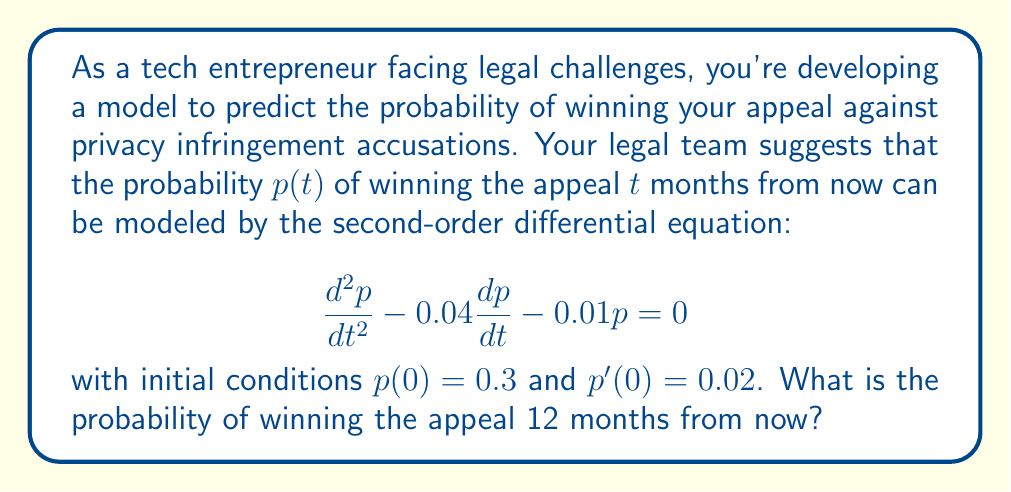Could you help me with this problem? To solve this problem, we need to follow these steps:

1) First, we recognize this as a second-order linear differential equation with constant coefficients. The characteristic equation is:

   $$r^2 - 0.04r - 0.01 = 0$$

2) Solving this quadratic equation:
   $$r = \frac{0.04 \pm \sqrt{0.04^2 + 4(0.01)}}{2} = \frac{0.04 \pm \sqrt{0.0416}}{2} = \frac{0.04 \pm 0.204}{2}$$

   So, $r_1 = 0.122$ and $r_2 = -0.082$

3) The general solution is therefore:
   $$p(t) = c_1e^{0.122t} + c_2e^{-0.082t}$$

4) To find $c_1$ and $c_2$, we use the initial conditions:

   $p(0) = 0.3$: $c_1 + c_2 = 0.3$
   $p'(0) = 0.02$: $0.122c_1 - 0.082c_2 = 0.02$

5) Solving these simultaneous equations:
   $c_1 = 0.1765$ and $c_2 = 0.1235$

6) Therefore, the particular solution is:
   $$p(t) = 0.1765e^{0.122t} + 0.1235e^{-0.082t}$$

7) To find the probability after 12 months, we substitute $t = 12$:

   $$p(12) = 0.1765e^{0.122(12)} + 0.1235e^{-0.082(12)}$$
   $$= 0.1765e^{1.464} + 0.1235e^{-0.984}$$
   $$= 0.1765(4.3233) + 0.1235(0.3739)$$
   $$= 0.7631 + 0.0462$$
   $$= 0.8093$$
Answer: The probability of winning the appeal 12 months from now is approximately 0.8093 or 80.93%. 